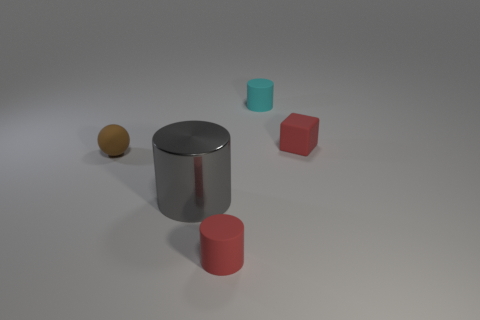What material is the cylinder on the left side of the cylinder in front of the big metal cylinder?
Offer a very short reply. Metal. There is a gray metal cylinder right of the ball; what size is it?
Offer a very short reply. Large. What number of purple objects are big spheres or large cylinders?
Keep it short and to the point. 0. Are there any other things that have the same material as the gray cylinder?
Make the answer very short. No. There is another red thing that is the same shape as the metal thing; what material is it?
Provide a succinct answer. Rubber. Are there the same number of tiny cyan matte things to the left of the cyan rubber object and tiny cyan balls?
Your answer should be very brief. Yes. How big is the matte thing that is both right of the matte ball and to the left of the cyan matte cylinder?
Ensure brevity in your answer.  Small. Is there any other thing of the same color as the metal thing?
Ensure brevity in your answer.  No. There is a red rubber object that is behind the tiny cylinder in front of the block; how big is it?
Offer a very short reply. Small. There is a tiny object that is both to the right of the tiny red cylinder and to the left of the tiny matte block; what is its color?
Provide a short and direct response. Cyan. 